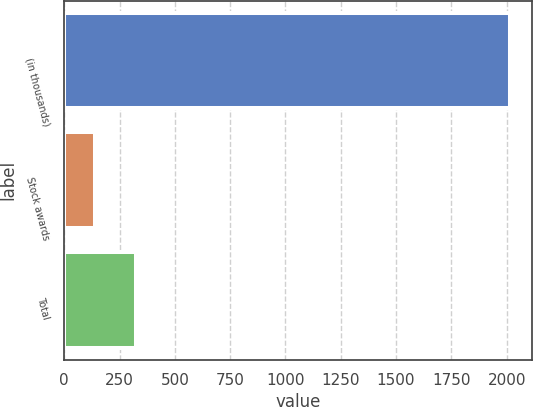<chart> <loc_0><loc_0><loc_500><loc_500><bar_chart><fcel>(in thousands)<fcel>Stock awards<fcel>Total<nl><fcel>2016<fcel>138<fcel>325.8<nl></chart> 